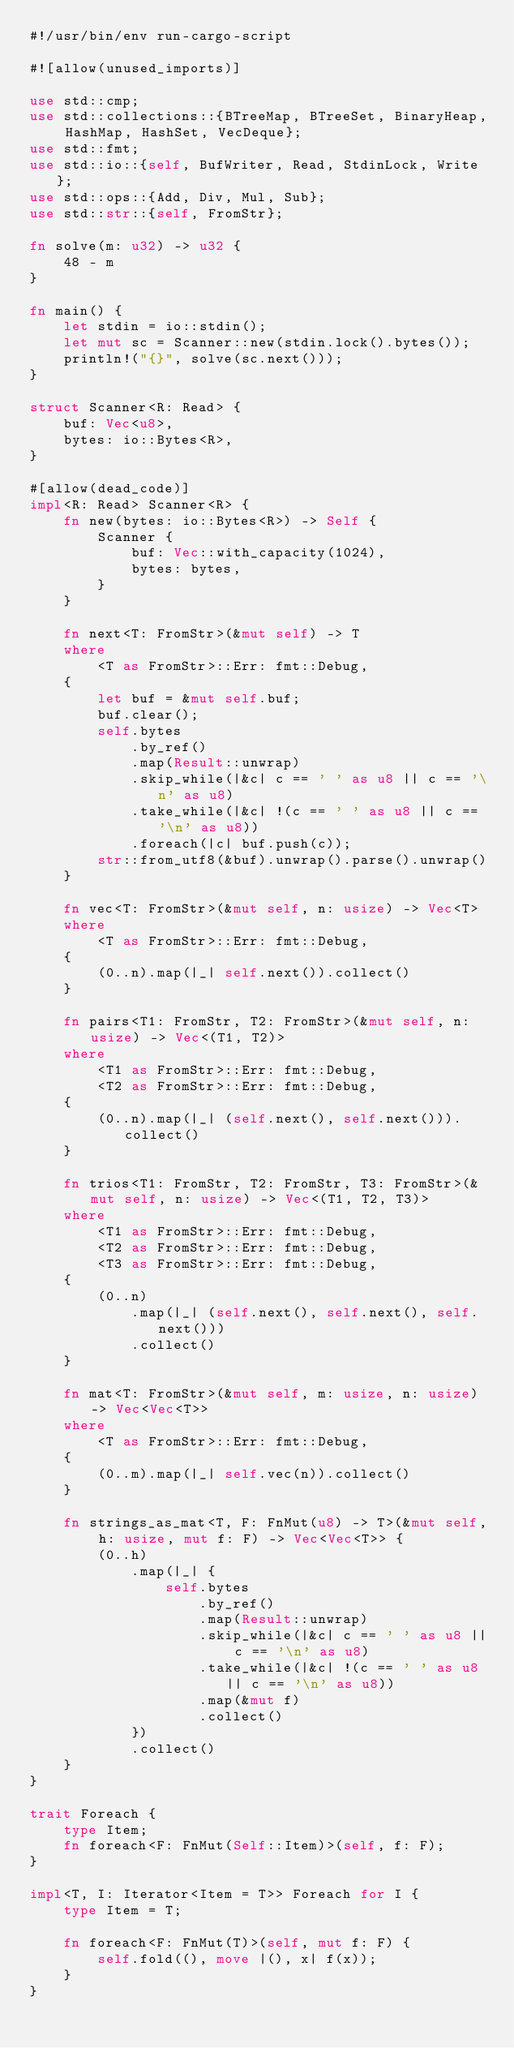Convert code to text. <code><loc_0><loc_0><loc_500><loc_500><_Rust_>#!/usr/bin/env run-cargo-script

#![allow(unused_imports)]

use std::cmp;
use std::collections::{BTreeMap, BTreeSet, BinaryHeap, HashMap, HashSet, VecDeque};
use std::fmt;
use std::io::{self, BufWriter, Read, StdinLock, Write};
use std::ops::{Add, Div, Mul, Sub};
use std::str::{self, FromStr};

fn solve(m: u32) -> u32 {
    48 - m
}

fn main() {
    let stdin = io::stdin();
    let mut sc = Scanner::new(stdin.lock().bytes());
    println!("{}", solve(sc.next()));
}

struct Scanner<R: Read> {
    buf: Vec<u8>,
    bytes: io::Bytes<R>,
}

#[allow(dead_code)]
impl<R: Read> Scanner<R> {
    fn new(bytes: io::Bytes<R>) -> Self {
        Scanner {
            buf: Vec::with_capacity(1024),
            bytes: bytes,
        }
    }

    fn next<T: FromStr>(&mut self) -> T
    where
        <T as FromStr>::Err: fmt::Debug,
    {
        let buf = &mut self.buf;
        buf.clear();
        self.bytes
            .by_ref()
            .map(Result::unwrap)
            .skip_while(|&c| c == ' ' as u8 || c == '\n' as u8)
            .take_while(|&c| !(c == ' ' as u8 || c == '\n' as u8))
            .foreach(|c| buf.push(c));
        str::from_utf8(&buf).unwrap().parse().unwrap()
    }

    fn vec<T: FromStr>(&mut self, n: usize) -> Vec<T>
    where
        <T as FromStr>::Err: fmt::Debug,
    {
        (0..n).map(|_| self.next()).collect()
    }

    fn pairs<T1: FromStr, T2: FromStr>(&mut self, n: usize) -> Vec<(T1, T2)>
    where
        <T1 as FromStr>::Err: fmt::Debug,
        <T2 as FromStr>::Err: fmt::Debug,
    {
        (0..n).map(|_| (self.next(), self.next())).collect()
    }

    fn trios<T1: FromStr, T2: FromStr, T3: FromStr>(&mut self, n: usize) -> Vec<(T1, T2, T3)>
    where
        <T1 as FromStr>::Err: fmt::Debug,
        <T2 as FromStr>::Err: fmt::Debug,
        <T3 as FromStr>::Err: fmt::Debug,
    {
        (0..n)
            .map(|_| (self.next(), self.next(), self.next()))
            .collect()
    }

    fn mat<T: FromStr>(&mut self, m: usize, n: usize) -> Vec<Vec<T>>
    where
        <T as FromStr>::Err: fmt::Debug,
    {
        (0..m).map(|_| self.vec(n)).collect()
    }

    fn strings_as_mat<T, F: FnMut(u8) -> T>(&mut self, h: usize, mut f: F) -> Vec<Vec<T>> {
        (0..h)
            .map(|_| {
                self.bytes
                    .by_ref()
                    .map(Result::unwrap)
                    .skip_while(|&c| c == ' ' as u8 || c == '\n' as u8)
                    .take_while(|&c| !(c == ' ' as u8 || c == '\n' as u8))
                    .map(&mut f)
                    .collect()
            })
            .collect()
    }
}

trait Foreach {
    type Item;
    fn foreach<F: FnMut(Self::Item)>(self, f: F);
}

impl<T, I: Iterator<Item = T>> Foreach for I {
    type Item = T;

    fn foreach<F: FnMut(T)>(self, mut f: F) {
        self.fold((), move |(), x| f(x));
    }
}
</code> 